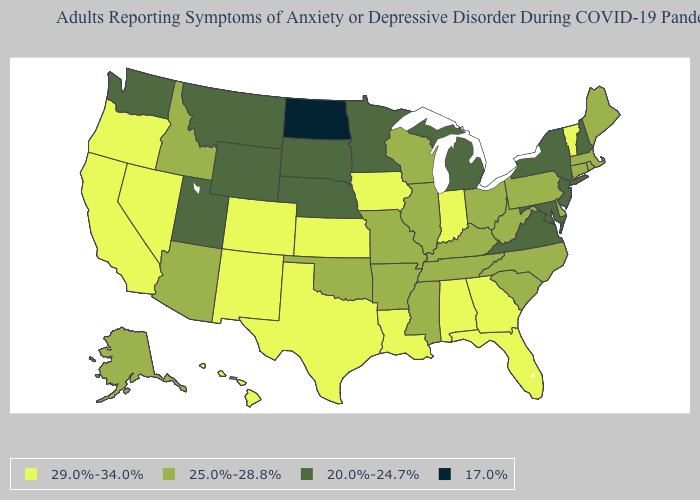What is the highest value in the USA?
Write a very short answer. 29.0%-34.0%. Name the states that have a value in the range 29.0%-34.0%?
Answer briefly. Alabama, California, Colorado, Florida, Georgia, Hawaii, Indiana, Iowa, Kansas, Louisiana, Nevada, New Mexico, Oregon, Texas, Vermont. What is the value of California?
Concise answer only. 29.0%-34.0%. Is the legend a continuous bar?
Short answer required. No. What is the value of Minnesota?
Give a very brief answer. 20.0%-24.7%. What is the lowest value in the USA?
Give a very brief answer. 17.0%. What is the value of North Dakota?
Concise answer only. 17.0%. Name the states that have a value in the range 25.0%-28.8%?
Short answer required. Alaska, Arizona, Arkansas, Connecticut, Delaware, Idaho, Illinois, Kentucky, Maine, Massachusetts, Mississippi, Missouri, North Carolina, Ohio, Oklahoma, Pennsylvania, Rhode Island, South Carolina, Tennessee, West Virginia, Wisconsin. Name the states that have a value in the range 29.0%-34.0%?
Quick response, please. Alabama, California, Colorado, Florida, Georgia, Hawaii, Indiana, Iowa, Kansas, Louisiana, Nevada, New Mexico, Oregon, Texas, Vermont. What is the value of Texas?
Be succinct. 29.0%-34.0%. How many symbols are there in the legend?
Concise answer only. 4. What is the value of Iowa?
Be succinct. 29.0%-34.0%. What is the highest value in the West ?
Answer briefly. 29.0%-34.0%. Among the states that border Montana , which have the highest value?
Quick response, please. Idaho. Among the states that border Kansas , which have the lowest value?
Short answer required. Nebraska. 